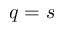<formula> <loc_0><loc_0><loc_500><loc_500>q = s</formula> 